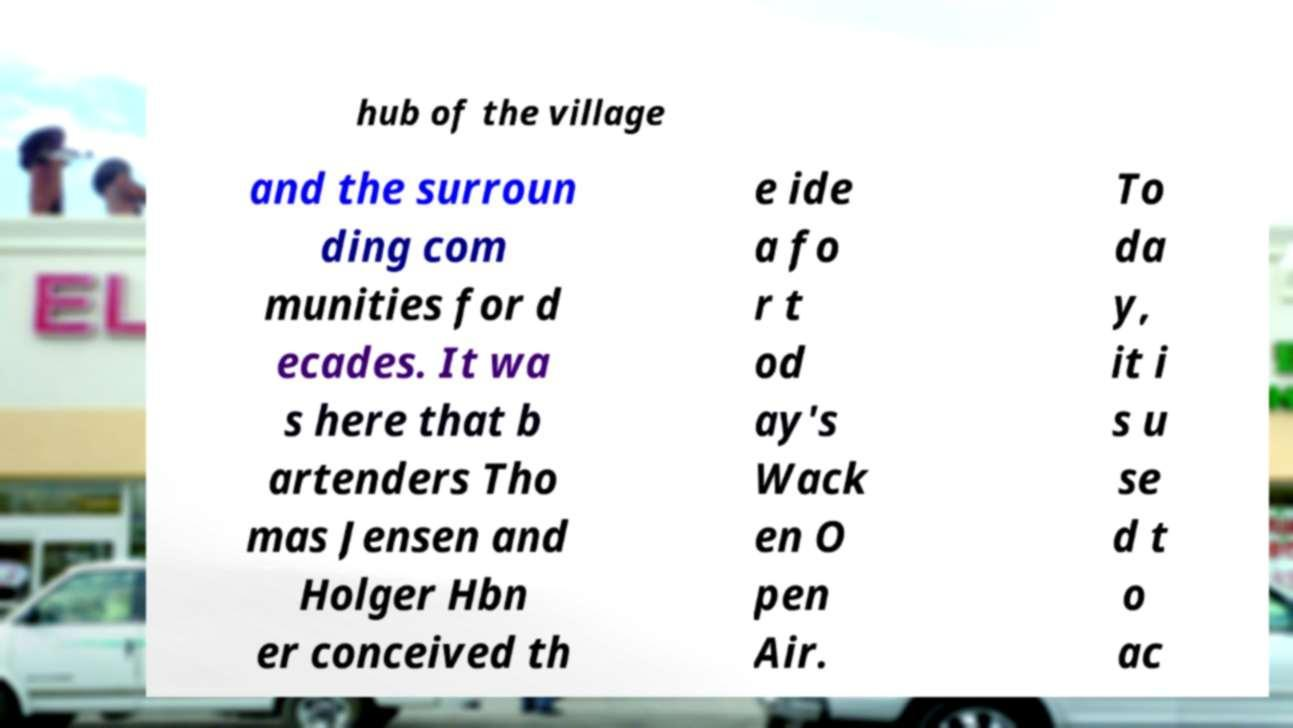Can you accurately transcribe the text from the provided image for me? hub of the village and the surroun ding com munities for d ecades. It wa s here that b artenders Tho mas Jensen and Holger Hbn er conceived th e ide a fo r t od ay's Wack en O pen Air. To da y, it i s u se d t o ac 